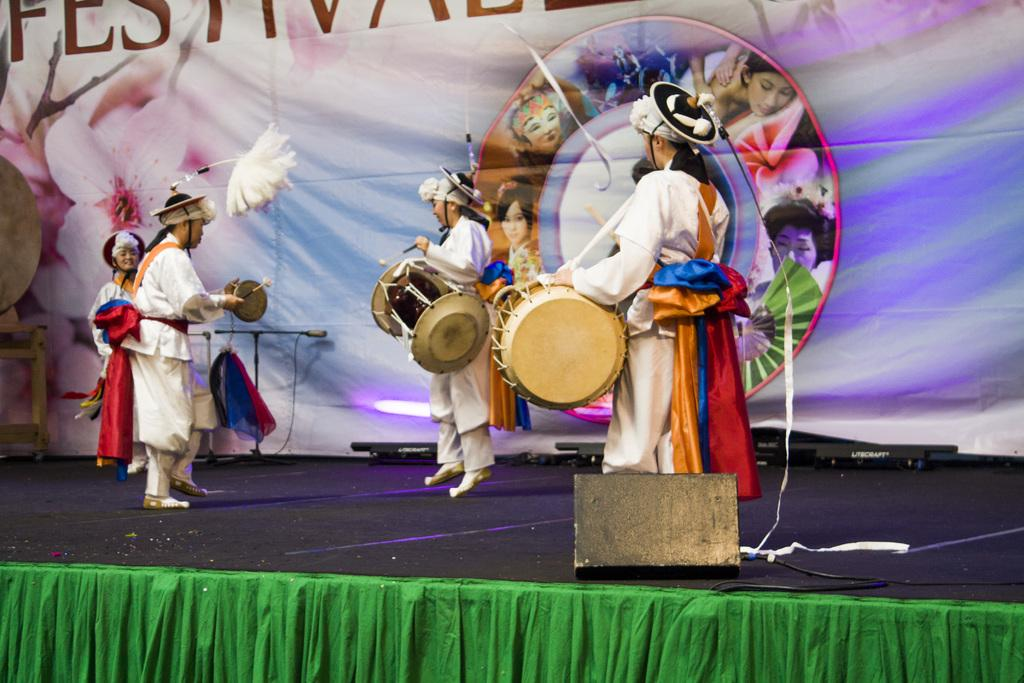What are the persons in the image doing? A: The persons in the image are playing musical instruments. What can be seen in the background of the image? There is a banner in the background of the image. What is the banner made of? The banner is made of cloth. How many eggs are visible on the calculator in the image? There is no calculator or eggs present in the image. What type of clothing is appropriate for the summer season in the image? The provided facts do not mention any clothing or the season, so we cannot determine the appropriate attire for summer from the image. 